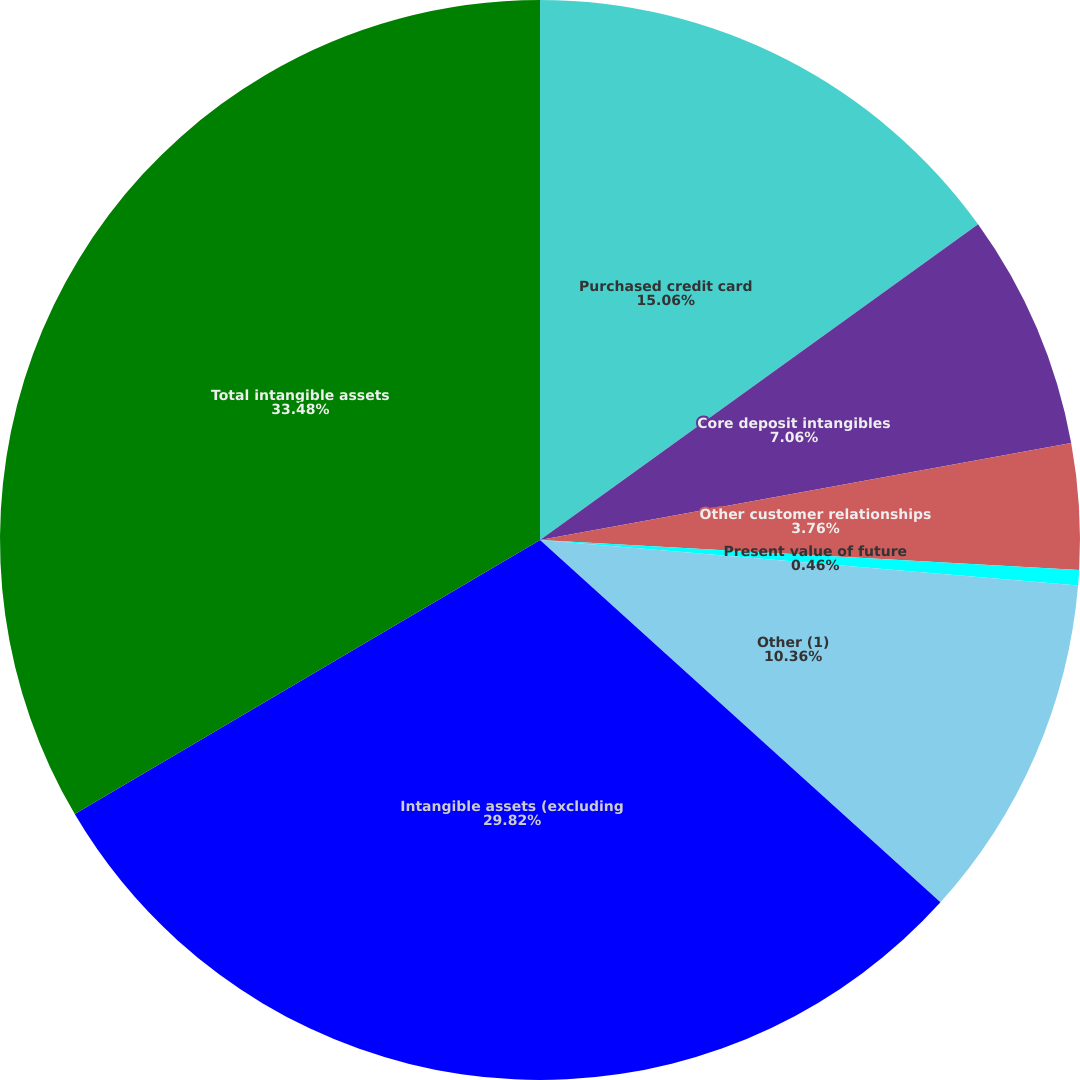Convert chart to OTSL. <chart><loc_0><loc_0><loc_500><loc_500><pie_chart><fcel>Purchased credit card<fcel>Core deposit intangibles<fcel>Other customer relationships<fcel>Present value of future<fcel>Other (1)<fcel>Intangible assets (excluding<fcel>Total intangible assets<nl><fcel>15.06%<fcel>7.06%<fcel>3.76%<fcel>0.46%<fcel>10.36%<fcel>29.82%<fcel>33.47%<nl></chart> 